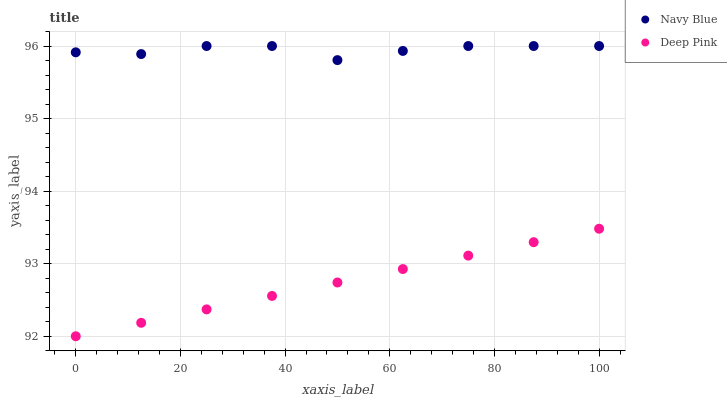Does Deep Pink have the minimum area under the curve?
Answer yes or no. Yes. Does Navy Blue have the maximum area under the curve?
Answer yes or no. Yes. Does Deep Pink have the maximum area under the curve?
Answer yes or no. No. Is Deep Pink the smoothest?
Answer yes or no. Yes. Is Navy Blue the roughest?
Answer yes or no. Yes. Is Deep Pink the roughest?
Answer yes or no. No. Does Deep Pink have the lowest value?
Answer yes or no. Yes. Does Navy Blue have the highest value?
Answer yes or no. Yes. Does Deep Pink have the highest value?
Answer yes or no. No. Is Deep Pink less than Navy Blue?
Answer yes or no. Yes. Is Navy Blue greater than Deep Pink?
Answer yes or no. Yes. Does Deep Pink intersect Navy Blue?
Answer yes or no. No. 